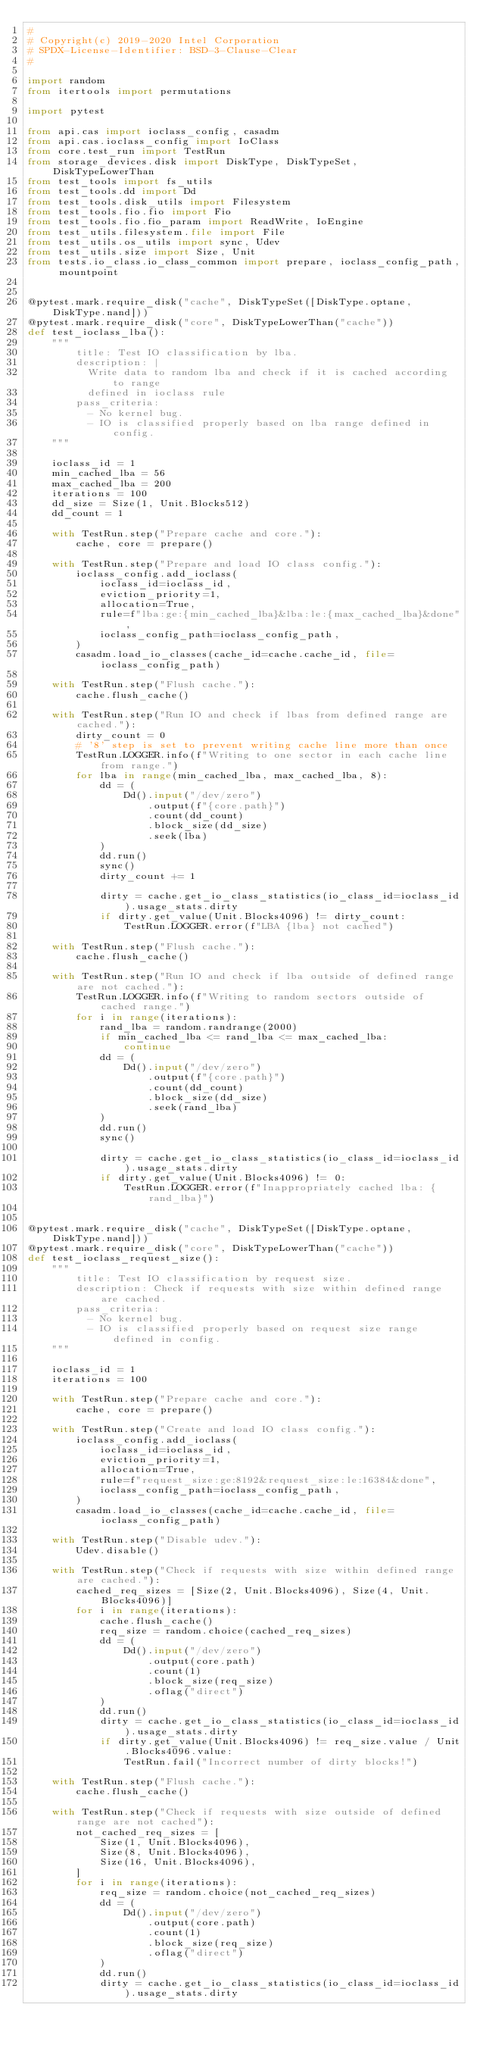Convert code to text. <code><loc_0><loc_0><loc_500><loc_500><_Python_>#
# Copyright(c) 2019-2020 Intel Corporation
# SPDX-License-Identifier: BSD-3-Clause-Clear
#

import random
from itertools import permutations

import pytest

from api.cas import ioclass_config, casadm
from api.cas.ioclass_config import IoClass
from core.test_run import TestRun
from storage_devices.disk import DiskType, DiskTypeSet, DiskTypeLowerThan
from test_tools import fs_utils
from test_tools.dd import Dd
from test_tools.disk_utils import Filesystem
from test_tools.fio.fio import Fio
from test_tools.fio.fio_param import ReadWrite, IoEngine
from test_utils.filesystem.file import File
from test_utils.os_utils import sync, Udev
from test_utils.size import Size, Unit
from tests.io_class.io_class_common import prepare, ioclass_config_path, mountpoint


@pytest.mark.require_disk("cache", DiskTypeSet([DiskType.optane, DiskType.nand]))
@pytest.mark.require_disk("core", DiskTypeLowerThan("cache"))
def test_ioclass_lba():
    """
        title: Test IO classification by lba.
        description: |
          Write data to random lba and check if it is cached according to range
          defined in ioclass rule
        pass_criteria:
          - No kernel bug.
          - IO is classified properly based on lba range defined in config.
    """

    ioclass_id = 1
    min_cached_lba = 56
    max_cached_lba = 200
    iterations = 100
    dd_size = Size(1, Unit.Blocks512)
    dd_count = 1

    with TestRun.step("Prepare cache and core."):
        cache, core = prepare()

    with TestRun.step("Prepare and load IO class config."):
        ioclass_config.add_ioclass(
            ioclass_id=ioclass_id,
            eviction_priority=1,
            allocation=True,
            rule=f"lba:ge:{min_cached_lba}&lba:le:{max_cached_lba}&done",
            ioclass_config_path=ioclass_config_path,
        )
        casadm.load_io_classes(cache_id=cache.cache_id, file=ioclass_config_path)

    with TestRun.step("Flush cache."):
        cache.flush_cache()

    with TestRun.step("Run IO and check if lbas from defined range are cached."):
        dirty_count = 0
        # '8' step is set to prevent writing cache line more than once
        TestRun.LOGGER.info(f"Writing to one sector in each cache line from range.")
        for lba in range(min_cached_lba, max_cached_lba, 8):
            dd = (
                Dd().input("/dev/zero")
                    .output(f"{core.path}")
                    .count(dd_count)
                    .block_size(dd_size)
                    .seek(lba)
            )
            dd.run()
            sync()
            dirty_count += 1

            dirty = cache.get_io_class_statistics(io_class_id=ioclass_id).usage_stats.dirty
            if dirty.get_value(Unit.Blocks4096) != dirty_count:
                TestRun.LOGGER.error(f"LBA {lba} not cached")

    with TestRun.step("Flush cache."):
        cache.flush_cache()

    with TestRun.step("Run IO and check if lba outside of defined range are not cached."):
        TestRun.LOGGER.info(f"Writing to random sectors outside of cached range.")
        for i in range(iterations):
            rand_lba = random.randrange(2000)
            if min_cached_lba <= rand_lba <= max_cached_lba:
                continue
            dd = (
                Dd().input("/dev/zero")
                    .output(f"{core.path}")
                    .count(dd_count)
                    .block_size(dd_size)
                    .seek(rand_lba)
            )
            dd.run()
            sync()

            dirty = cache.get_io_class_statistics(io_class_id=ioclass_id).usage_stats.dirty
            if dirty.get_value(Unit.Blocks4096) != 0:
                TestRun.LOGGER.error(f"Inappropriately cached lba: {rand_lba}")


@pytest.mark.require_disk("cache", DiskTypeSet([DiskType.optane, DiskType.nand]))
@pytest.mark.require_disk("core", DiskTypeLowerThan("cache"))
def test_ioclass_request_size():
    """
        title: Test IO classification by request size.
        description: Check if requests with size within defined range are cached.
        pass_criteria:
          - No kernel bug.
          - IO is classified properly based on request size range defined in config.
    """

    ioclass_id = 1
    iterations = 100

    with TestRun.step("Prepare cache and core."):
        cache, core = prepare()

    with TestRun.step("Create and load IO class config."):
        ioclass_config.add_ioclass(
            ioclass_id=ioclass_id,
            eviction_priority=1,
            allocation=True,
            rule=f"request_size:ge:8192&request_size:le:16384&done",
            ioclass_config_path=ioclass_config_path,
        )
        casadm.load_io_classes(cache_id=cache.cache_id, file=ioclass_config_path)

    with TestRun.step("Disable udev."):
        Udev.disable()

    with TestRun.step("Check if requests with size within defined range are cached."):
        cached_req_sizes = [Size(2, Unit.Blocks4096), Size(4, Unit.Blocks4096)]
        for i in range(iterations):
            cache.flush_cache()
            req_size = random.choice(cached_req_sizes)
            dd = (
                Dd().input("/dev/zero")
                    .output(core.path)
                    .count(1)
                    .block_size(req_size)
                    .oflag("direct")
            )
            dd.run()
            dirty = cache.get_io_class_statistics(io_class_id=ioclass_id).usage_stats.dirty
            if dirty.get_value(Unit.Blocks4096) != req_size.value / Unit.Blocks4096.value:
                TestRun.fail("Incorrect number of dirty blocks!")

    with TestRun.step("Flush cache."):
        cache.flush_cache()

    with TestRun.step("Check if requests with size outside of defined range are not cached"):
        not_cached_req_sizes = [
            Size(1, Unit.Blocks4096),
            Size(8, Unit.Blocks4096),
            Size(16, Unit.Blocks4096),
        ]
        for i in range(iterations):
            req_size = random.choice(not_cached_req_sizes)
            dd = (
                Dd().input("/dev/zero")
                    .output(core.path)
                    .count(1)
                    .block_size(req_size)
                    .oflag("direct")
            )
            dd.run()
            dirty = cache.get_io_class_statistics(io_class_id=ioclass_id).usage_stats.dirty</code> 